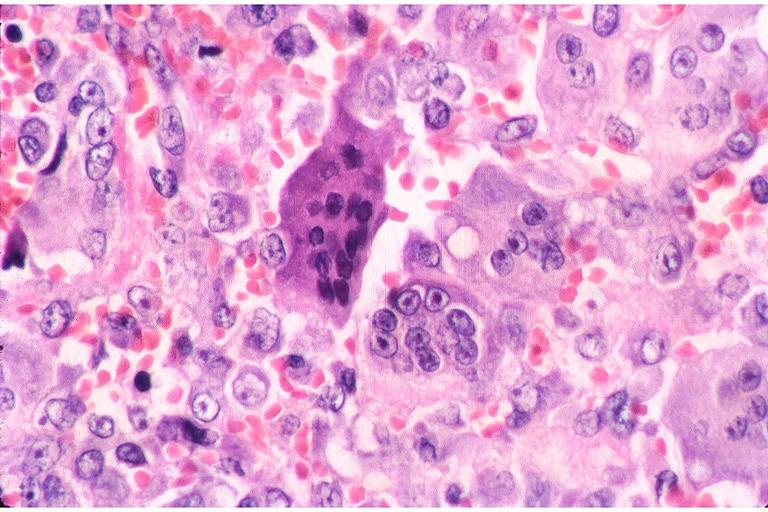where is this?
Answer the question using a single word or phrase. Oral 